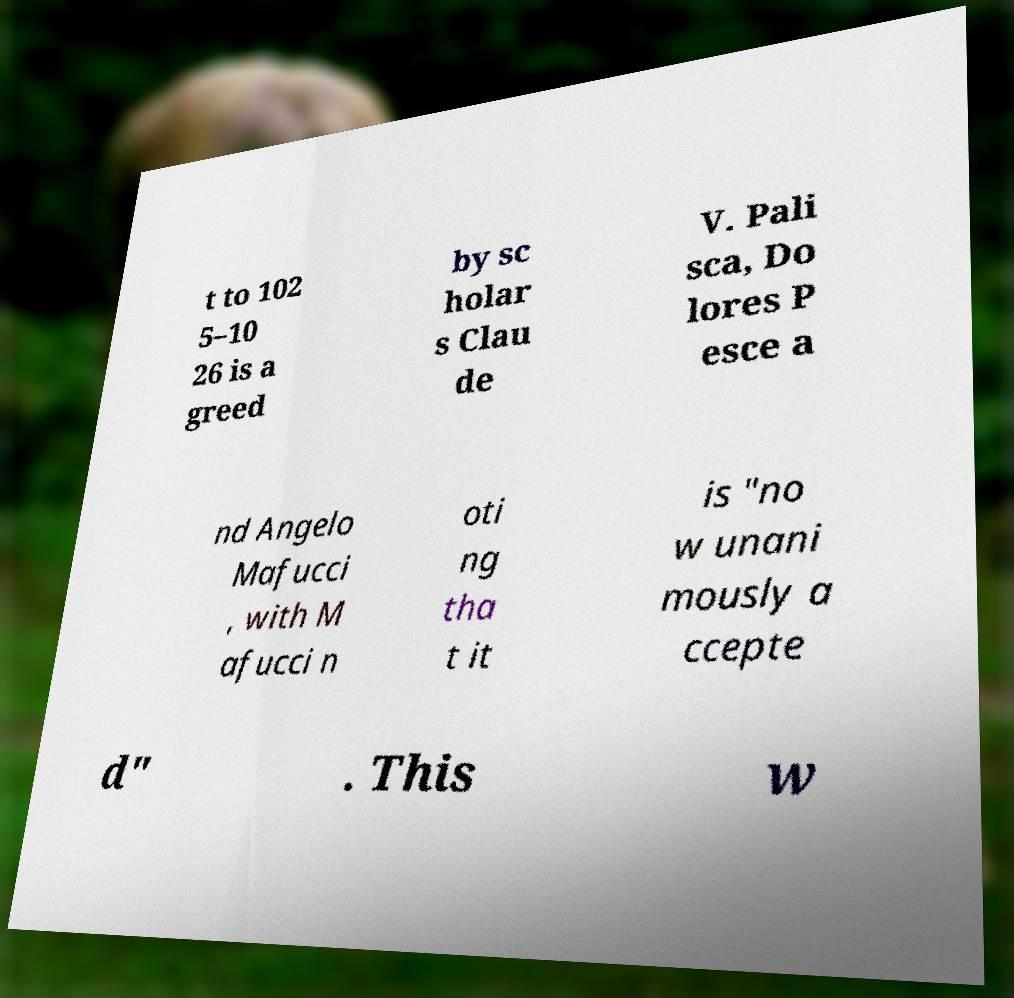Please read and relay the text visible in this image. What does it say? t to 102 5–10 26 is a greed by sc holar s Clau de V. Pali sca, Do lores P esce a nd Angelo Mafucci , with M afucci n oti ng tha t it is "no w unani mously a ccepte d" . This w 